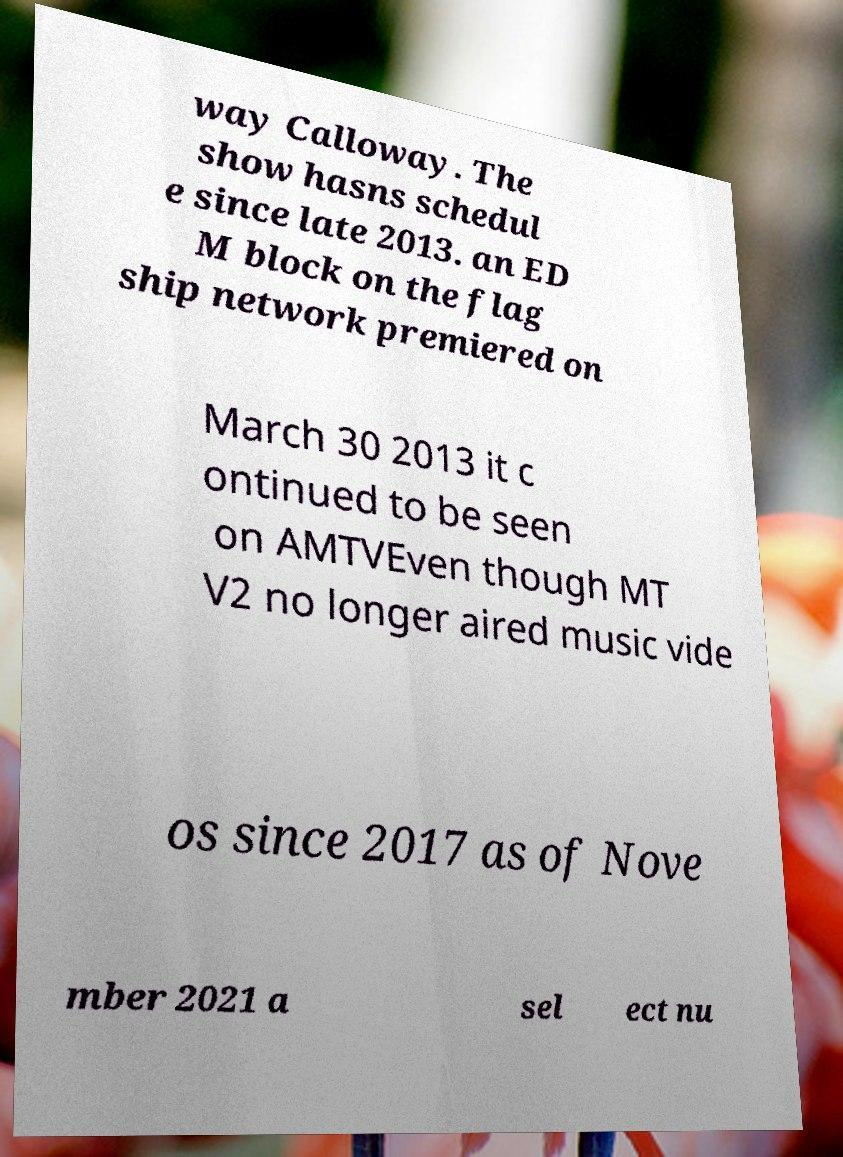For documentation purposes, I need the text within this image transcribed. Could you provide that? way Calloway. The show hasns schedul e since late 2013. an ED M block on the flag ship network premiered on March 30 2013 it c ontinued to be seen on AMTVEven though MT V2 no longer aired music vide os since 2017 as of Nove mber 2021 a sel ect nu 